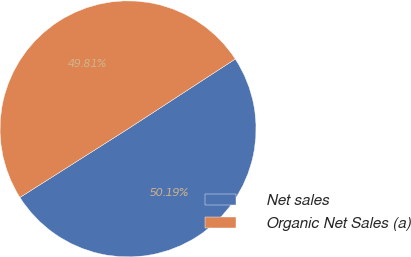Convert chart. <chart><loc_0><loc_0><loc_500><loc_500><pie_chart><fcel>Net sales<fcel>Organic Net Sales (a)<nl><fcel>50.19%<fcel>49.81%<nl></chart> 